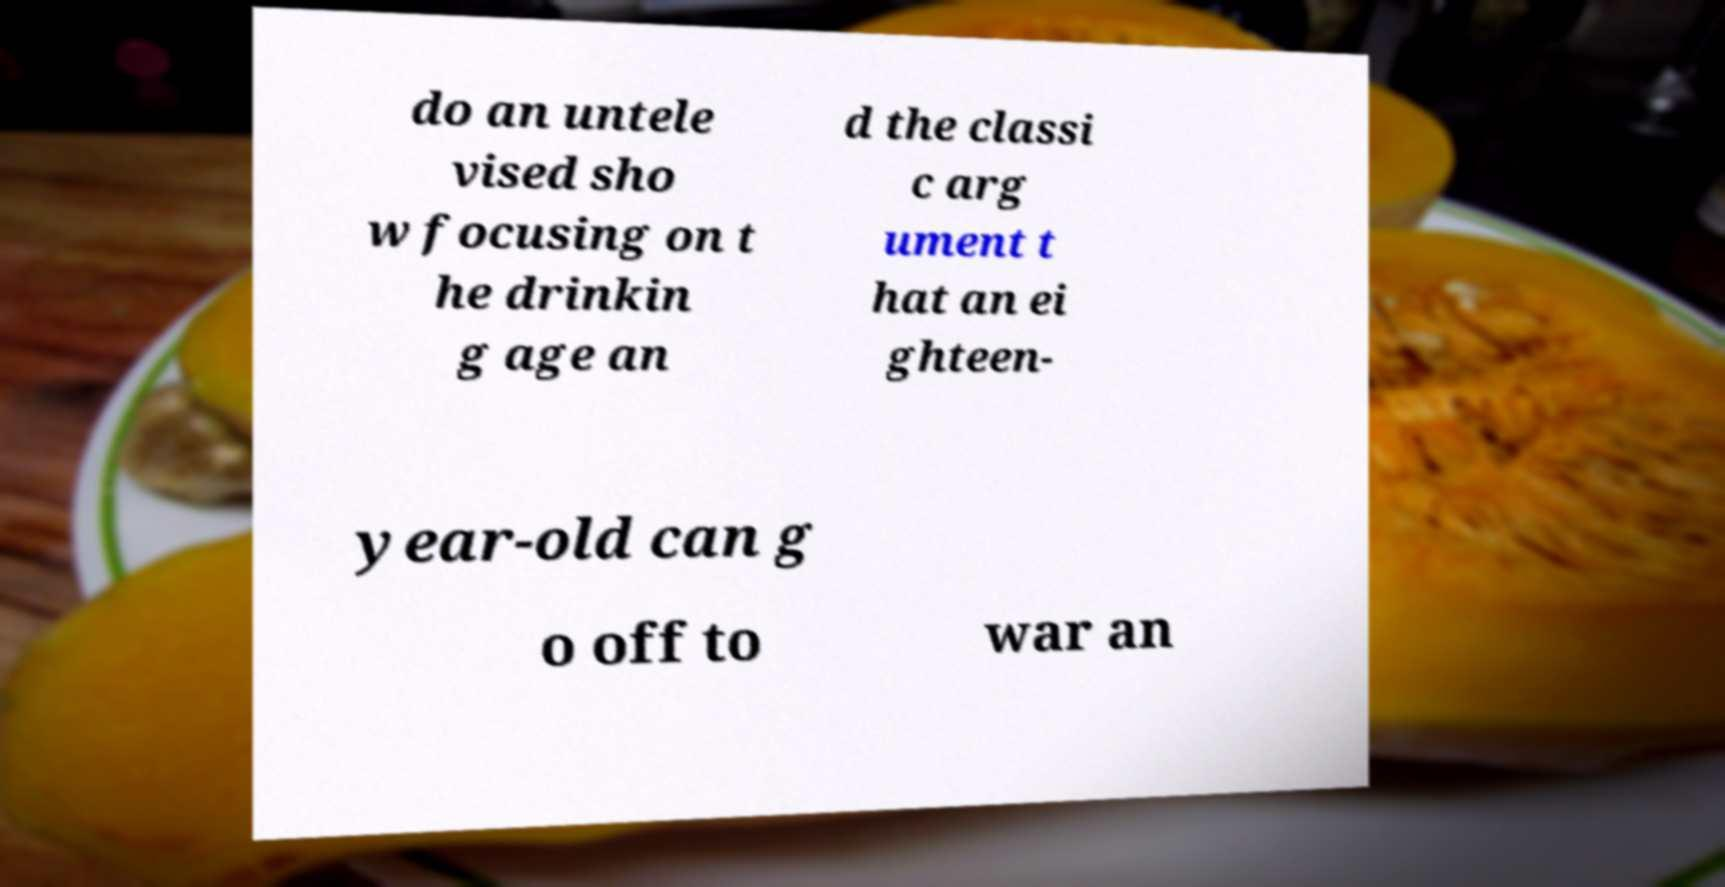Can you accurately transcribe the text from the provided image for me? do an untele vised sho w focusing on t he drinkin g age an d the classi c arg ument t hat an ei ghteen- year-old can g o off to war an 